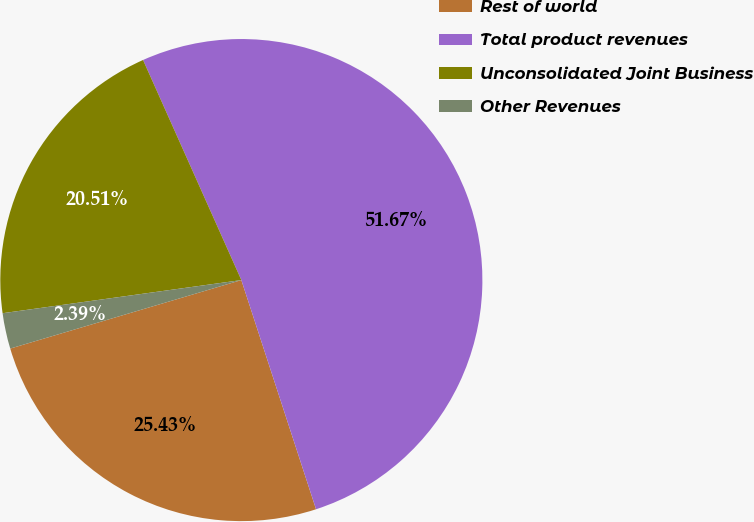Convert chart to OTSL. <chart><loc_0><loc_0><loc_500><loc_500><pie_chart><fcel>Rest of world<fcel>Total product revenues<fcel>Unconsolidated Joint Business<fcel>Other Revenues<nl><fcel>25.43%<fcel>51.67%<fcel>20.51%<fcel>2.39%<nl></chart> 